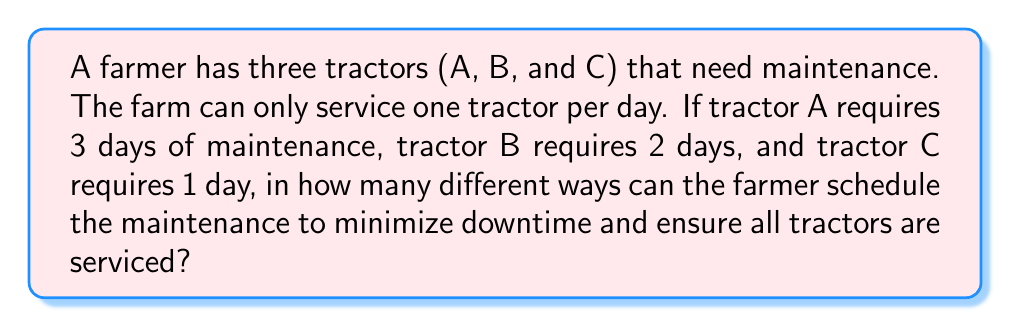Solve this math problem. Let's approach this step-by-step using logical reasoning:

1) First, we need to understand what the question is asking. We're looking for the number of different ways to arrange the maintenance schedule for the three tractors.

2) We can represent this as a permutation problem. However, it's not a straightforward permutation because each tractor requires multiple days of maintenance.

3) Let's represent each day of maintenance for each tractor:
   Tractor A: A1, A2, A3
   Tractor B: B1, B2
   Tractor C: C1

4) Now, we need to arrange these 6 elements (A1, A2, A3, B1, B2, C1) in a way that respects the continuity of each tractor's maintenance.

5) We can think of this as arranging 3 blocks (A, B, and C), where the order within each block is fixed.

6) This is equivalent to finding the number of permutations of 3 distinct objects, which is given by the formula:

   $$P(3) = 3! = 3 \times 2 \times 1 = 6$$

Therefore, there are 6 different ways to schedule the maintenance.

The possible schedules are:
1. A-B-C: A1,A2,A3,B1,B2,C1
2. A-C-B: A1,A2,A3,C1,B1,B2
3. B-A-C: B1,B2,A1,A2,A3,C1
4. B-C-A: B1,B2,C1,A1,A2,A3
5. C-A-B: C1,A1,A2,A3,B1,B2
6. C-B-A: C1,B1,B2,A1,A2,A3
Answer: 6 different ways 